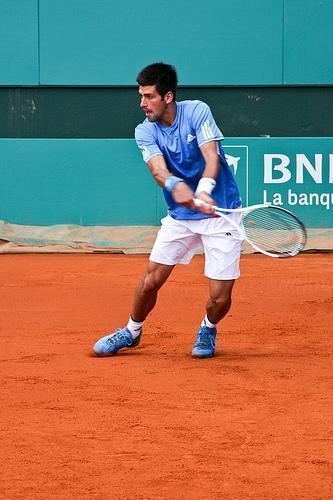How many people are in the picture?
Give a very brief answer. 1. 